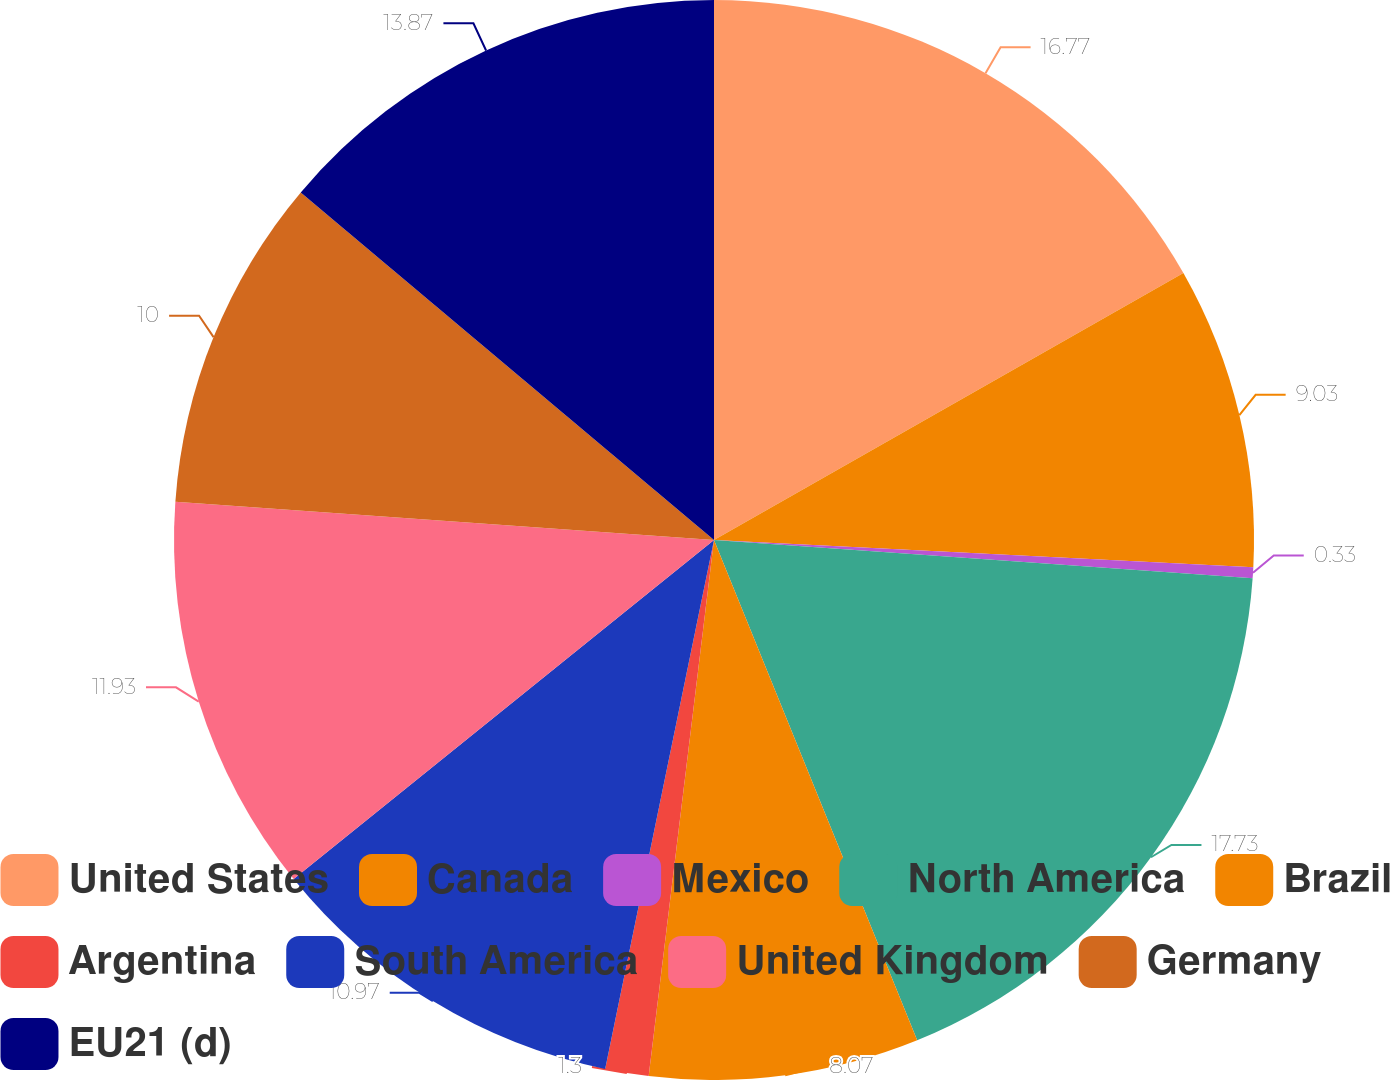<chart> <loc_0><loc_0><loc_500><loc_500><pie_chart><fcel>United States<fcel>Canada<fcel>Mexico<fcel>North America<fcel>Brazil<fcel>Argentina<fcel>South America<fcel>United Kingdom<fcel>Germany<fcel>EU21 (d)<nl><fcel>16.77%<fcel>9.03%<fcel>0.33%<fcel>17.73%<fcel>8.07%<fcel>1.3%<fcel>10.97%<fcel>11.93%<fcel>10.0%<fcel>13.87%<nl></chart> 